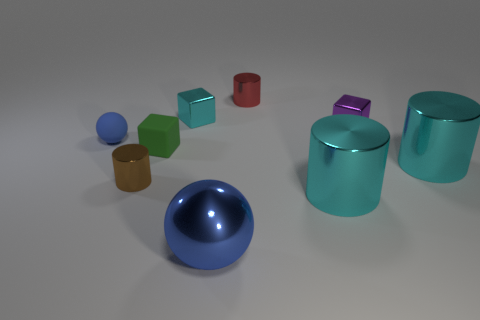The cyan object that is in front of the small cylinder that is on the left side of the ball that is in front of the green matte cube is made of what material?
Make the answer very short. Metal. There is a big blue metal object in front of the tiny red shiny thing; is it the same shape as the rubber thing behind the small green rubber cube?
Keep it short and to the point. Yes. What color is the tiny metal block that is on the right side of the cyan thing to the left of the big blue metallic sphere?
Ensure brevity in your answer.  Purple. What number of cylinders are purple metal things or small rubber things?
Offer a very short reply. 0. There is a tiny cylinder in front of the tiny thing right of the small red thing; how many matte balls are to the left of it?
Give a very brief answer. 1. There is a object that is the same color as the metal sphere; what size is it?
Your response must be concise. Small. Are there any yellow cylinders that have the same material as the small cyan object?
Make the answer very short. No. Are the tiny red cylinder and the tiny green cube made of the same material?
Make the answer very short. No. There is a shiny cube behind the tiny purple thing; what number of small cubes are right of it?
Offer a very short reply. 1. How many gray objects are either shiny cylinders or small rubber spheres?
Your response must be concise. 0. 